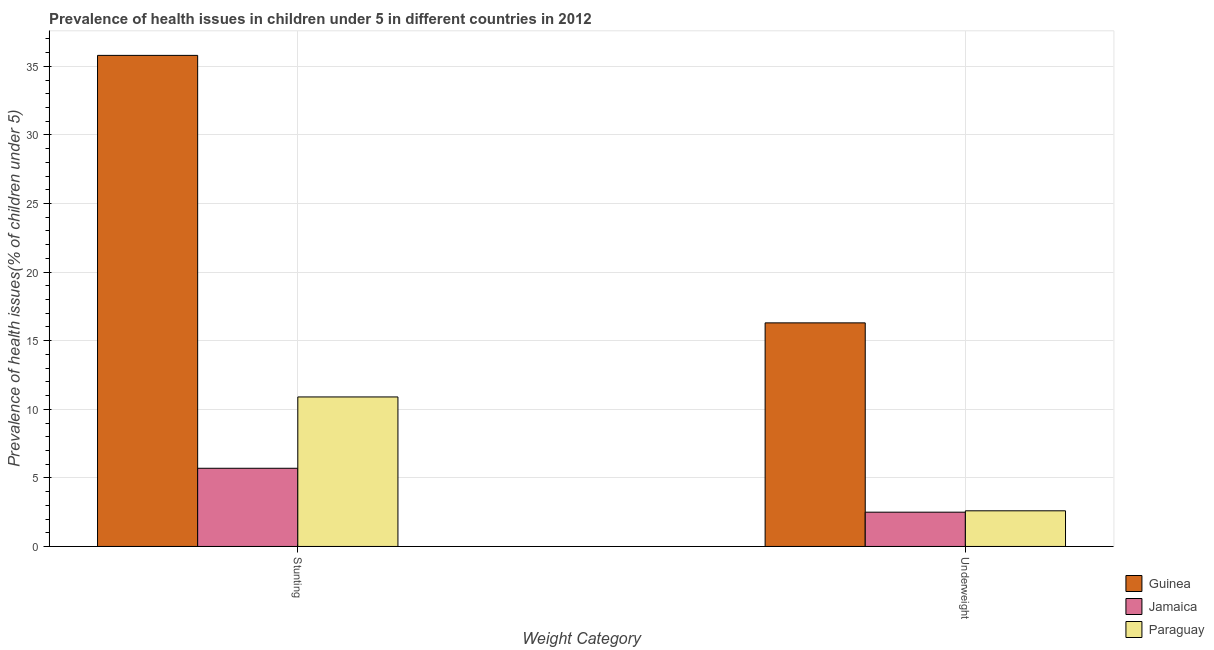How many groups of bars are there?
Ensure brevity in your answer.  2. Are the number of bars per tick equal to the number of legend labels?
Keep it short and to the point. Yes. Are the number of bars on each tick of the X-axis equal?
Your answer should be compact. Yes. What is the label of the 2nd group of bars from the left?
Ensure brevity in your answer.  Underweight. What is the percentage of underweight children in Jamaica?
Your response must be concise. 2.5. Across all countries, what is the maximum percentage of underweight children?
Provide a short and direct response. 16.3. Across all countries, what is the minimum percentage of underweight children?
Provide a short and direct response. 2.5. In which country was the percentage of stunted children maximum?
Offer a very short reply. Guinea. In which country was the percentage of underweight children minimum?
Keep it short and to the point. Jamaica. What is the total percentage of underweight children in the graph?
Keep it short and to the point. 21.4. What is the difference between the percentage of underweight children in Jamaica and that in Paraguay?
Offer a very short reply. -0.1. What is the difference between the percentage of underweight children in Paraguay and the percentage of stunted children in Guinea?
Keep it short and to the point. -33.2. What is the average percentage of stunted children per country?
Ensure brevity in your answer.  17.47. What is the difference between the percentage of stunted children and percentage of underweight children in Paraguay?
Your response must be concise. 8.3. What is the ratio of the percentage of underweight children in Paraguay to that in Guinea?
Give a very brief answer. 0.16. Is the percentage of stunted children in Paraguay less than that in Jamaica?
Ensure brevity in your answer.  No. What does the 2nd bar from the left in Stunting represents?
Make the answer very short. Jamaica. What does the 2nd bar from the right in Underweight represents?
Offer a very short reply. Jamaica. Are all the bars in the graph horizontal?
Your response must be concise. No. What is the difference between two consecutive major ticks on the Y-axis?
Give a very brief answer. 5. Does the graph contain any zero values?
Offer a very short reply. No. Does the graph contain grids?
Make the answer very short. Yes. How are the legend labels stacked?
Offer a terse response. Vertical. What is the title of the graph?
Provide a short and direct response. Prevalence of health issues in children under 5 in different countries in 2012. Does "Congo (Democratic)" appear as one of the legend labels in the graph?
Your response must be concise. No. What is the label or title of the X-axis?
Your answer should be compact. Weight Category. What is the label or title of the Y-axis?
Offer a terse response. Prevalence of health issues(% of children under 5). What is the Prevalence of health issues(% of children under 5) of Guinea in Stunting?
Offer a terse response. 35.8. What is the Prevalence of health issues(% of children under 5) of Jamaica in Stunting?
Provide a short and direct response. 5.7. What is the Prevalence of health issues(% of children under 5) of Paraguay in Stunting?
Provide a short and direct response. 10.9. What is the Prevalence of health issues(% of children under 5) of Guinea in Underweight?
Your response must be concise. 16.3. What is the Prevalence of health issues(% of children under 5) in Paraguay in Underweight?
Provide a short and direct response. 2.6. Across all Weight Category, what is the maximum Prevalence of health issues(% of children under 5) of Guinea?
Give a very brief answer. 35.8. Across all Weight Category, what is the maximum Prevalence of health issues(% of children under 5) in Jamaica?
Provide a short and direct response. 5.7. Across all Weight Category, what is the maximum Prevalence of health issues(% of children under 5) in Paraguay?
Offer a very short reply. 10.9. Across all Weight Category, what is the minimum Prevalence of health issues(% of children under 5) in Guinea?
Provide a succinct answer. 16.3. Across all Weight Category, what is the minimum Prevalence of health issues(% of children under 5) of Jamaica?
Your answer should be very brief. 2.5. Across all Weight Category, what is the minimum Prevalence of health issues(% of children under 5) of Paraguay?
Give a very brief answer. 2.6. What is the total Prevalence of health issues(% of children under 5) in Guinea in the graph?
Make the answer very short. 52.1. What is the total Prevalence of health issues(% of children under 5) of Jamaica in the graph?
Offer a terse response. 8.2. What is the difference between the Prevalence of health issues(% of children under 5) of Guinea in Stunting and that in Underweight?
Provide a succinct answer. 19.5. What is the difference between the Prevalence of health issues(% of children under 5) of Jamaica in Stunting and that in Underweight?
Ensure brevity in your answer.  3.2. What is the difference between the Prevalence of health issues(% of children under 5) of Paraguay in Stunting and that in Underweight?
Your answer should be very brief. 8.3. What is the difference between the Prevalence of health issues(% of children under 5) in Guinea in Stunting and the Prevalence of health issues(% of children under 5) in Jamaica in Underweight?
Ensure brevity in your answer.  33.3. What is the difference between the Prevalence of health issues(% of children under 5) in Guinea in Stunting and the Prevalence of health issues(% of children under 5) in Paraguay in Underweight?
Keep it short and to the point. 33.2. What is the average Prevalence of health issues(% of children under 5) in Guinea per Weight Category?
Keep it short and to the point. 26.05. What is the average Prevalence of health issues(% of children under 5) in Jamaica per Weight Category?
Your answer should be very brief. 4.1. What is the average Prevalence of health issues(% of children under 5) of Paraguay per Weight Category?
Your answer should be compact. 6.75. What is the difference between the Prevalence of health issues(% of children under 5) in Guinea and Prevalence of health issues(% of children under 5) in Jamaica in Stunting?
Offer a terse response. 30.1. What is the difference between the Prevalence of health issues(% of children under 5) in Guinea and Prevalence of health issues(% of children under 5) in Paraguay in Stunting?
Give a very brief answer. 24.9. What is the difference between the Prevalence of health issues(% of children under 5) of Jamaica and Prevalence of health issues(% of children under 5) of Paraguay in Stunting?
Your answer should be very brief. -5.2. What is the difference between the Prevalence of health issues(% of children under 5) of Guinea and Prevalence of health issues(% of children under 5) of Jamaica in Underweight?
Make the answer very short. 13.8. What is the ratio of the Prevalence of health issues(% of children under 5) in Guinea in Stunting to that in Underweight?
Provide a short and direct response. 2.2. What is the ratio of the Prevalence of health issues(% of children under 5) in Jamaica in Stunting to that in Underweight?
Your answer should be very brief. 2.28. What is the ratio of the Prevalence of health issues(% of children under 5) in Paraguay in Stunting to that in Underweight?
Keep it short and to the point. 4.19. What is the difference between the highest and the second highest Prevalence of health issues(% of children under 5) of Paraguay?
Provide a short and direct response. 8.3. What is the difference between the highest and the lowest Prevalence of health issues(% of children under 5) in Jamaica?
Offer a very short reply. 3.2. 